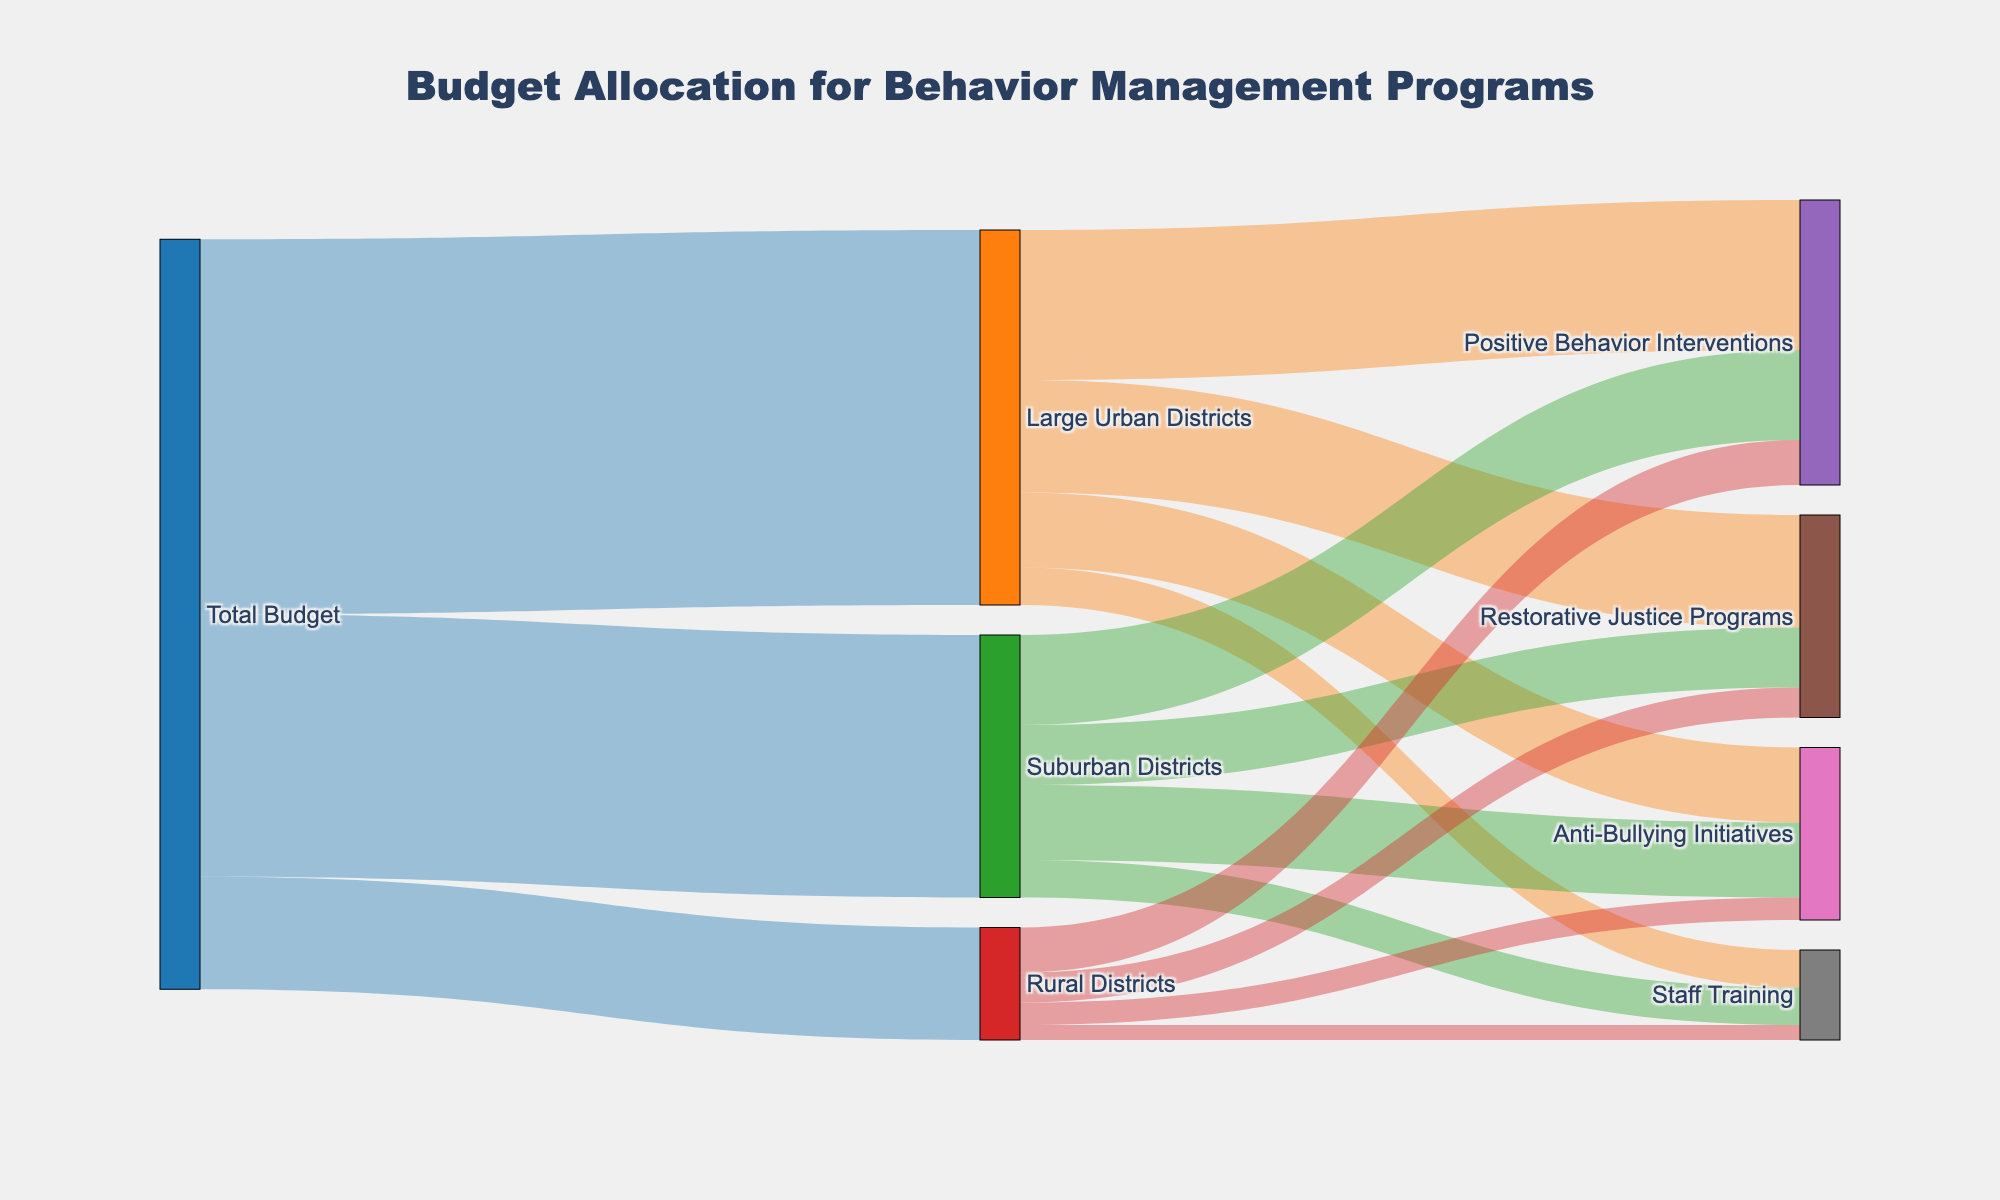what is the total budget allocated to suburban districts? The total budget allocated to suburban districts can be determined by looking at the flow from "Total Budget" to "Suburban Districts." The value is given as 3,500,000.
Answer: 3,500,000 How many categories are under the large urban districts budget allocation? To find the number of categories under the budget allocation for large urban districts, we need to count the flow lines from "Large Urban Districts" to its target categories. There are four: "Positive Behavior Interventions," "Restorative Justice Programs," "Anti-Bullying Initiatives," and "Staff Training."
Answer: 4 Which category receives the largest budget in rural districts? To find the category that receives the largest budget in rural districts, we look at the values of the flows from "Rural Districts" to its target categories. "Positive Behavior Interventions" receives 600,000, which is the largest.
Answer: Positive Behavior Interventions What's the difference in budget allocation between anti-bullying initiatives in large urban districts and rural districts? First, find the values allocated to anti-bullying initiatives in large urban and rural districts: 1,000,000 and 300,000, respectively. The difference is 1,000,000 - 300,000 = 700,000.
Answer: 700,000 What percentage of the total budget goes to restorative justice programs in all districts? To calculate the percentage, we need the total budget and the sum allocated to restorative justice programs: Large Urban Districts (1,500,000) + Suburban Districts (800,000) + Rural Districts (400,000) = 2,700,000. The total budget is 10,000,000. So, the percentage is (2,700,000 / 10,000,000) * 100 = 27%.
Answer: 27% How does the budget allocation for positive behavior interventions in suburban districts compare to large urban districts? The budget allocations are 1,200,000 for suburban districts and 2,000,000 for large urban districts. The allocation in suburban districts is less by 2,000,000 - 1,200,000 = 800,000.
Answer: Suburban districts receive 800,000 less What's the total budget allocated to all categories under large urban districts? Add the budgets for all target categories under large urban districts: 2,000,000 (Positive Behavior Interventions) + 1,500,000 (Restorative Justice Programs) + 1,000,000 (Anti-Bullying Initiatives) + 500,000 (Staff Training) = 5,000,000.
Answer: 5,000,000 Which district receives the least amount of total budget? Compare the total budgets allocated to each district: Large Urban Districts (5,000,000), Suburban Districts (3,500,000), and Rural Districts (1,500,000). The rural districts receive the least.
Answer: Rural Districts 